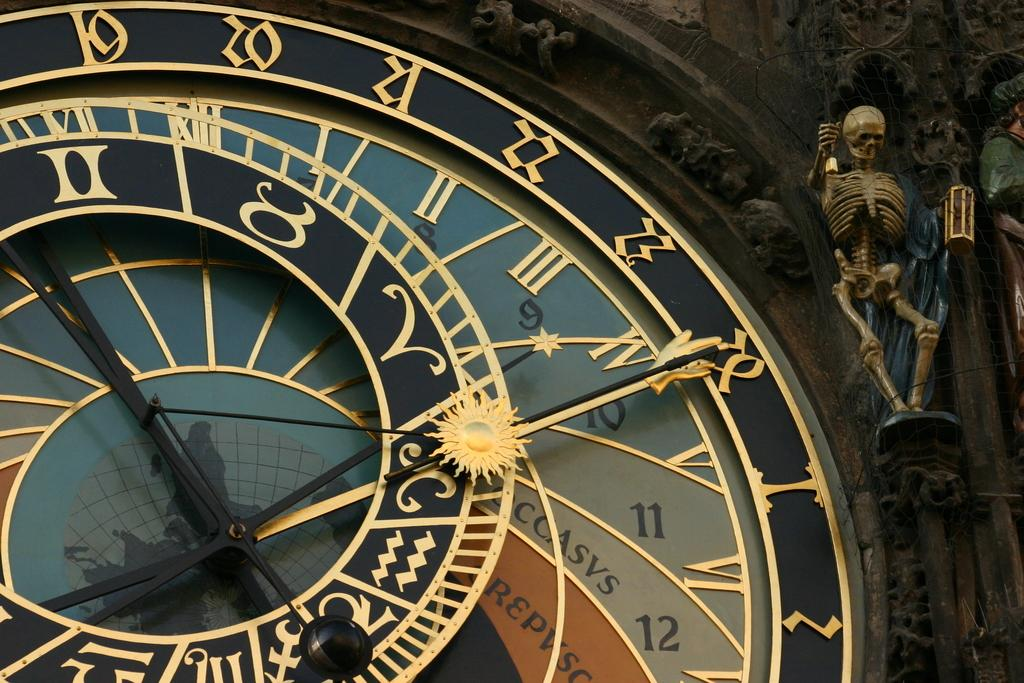<image>
Create a compact narrative representing the image presented. A strange clock has the number 9 through 12 on the side of the face, and a skeleton nearby. 